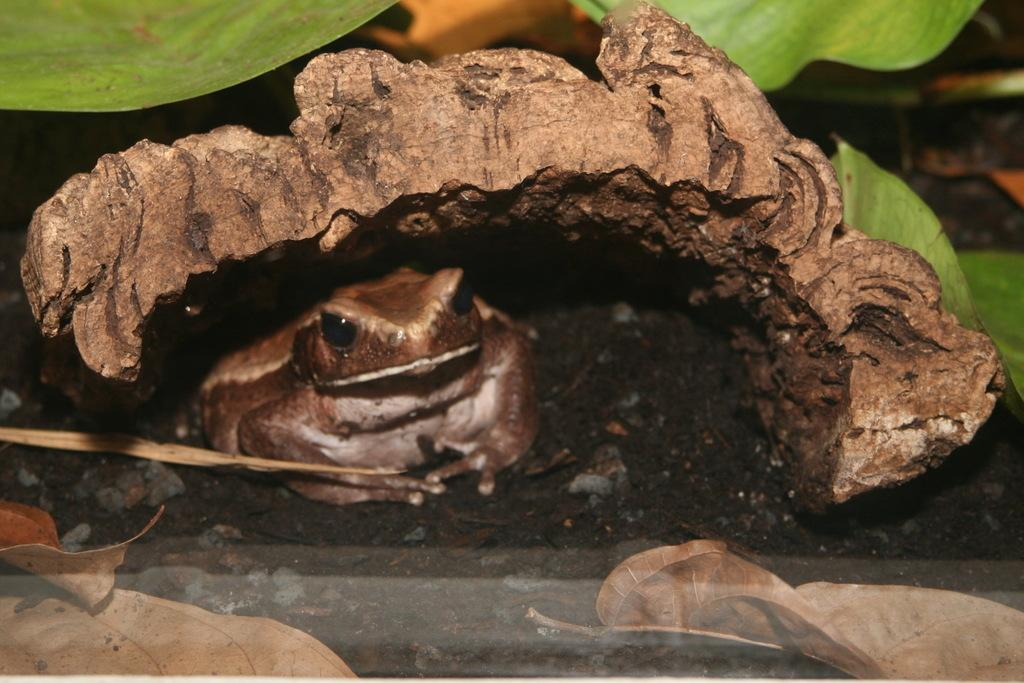What animal is in the picture? There is a frog in the picture. Where is the frog located in the image? The frog is sitting under some leaves. What is the color of the frog? The frog is brown in color. What can be seen on the ground near the frog? There are dried leaves on the path near the frog. Can you tell me how many boats are in the picture? There are no boats present in the picture; it features a frog sitting under some leaves. What type of amusement park can be seen in the background of the image? There is no amusement park visible in the image; it focuses on the frog and its surroundings. 